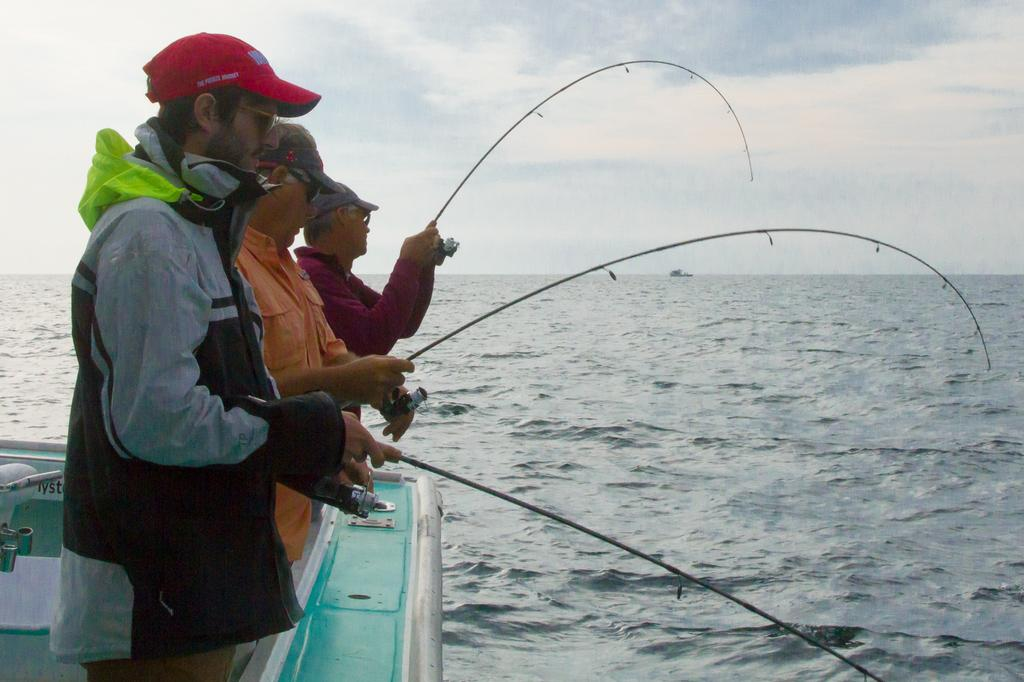How many people are in the image? There are three people standing to the left side of the image. What are the people doing in the image? The people are fishing. What can be seen in the background of the image? There is water and sky visible in the background of the image. What is the condition of the sky in the image? There are clouds in the sky. Can you tell me the tendency of the frog to jump in the image? There is no frog present in the image, so it is not possible to determine its tendency to jump. 